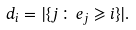<formula> <loc_0><loc_0><loc_500><loc_500>d _ { i } = | \{ j \colon e _ { j } \geqslant i \} | .</formula> 